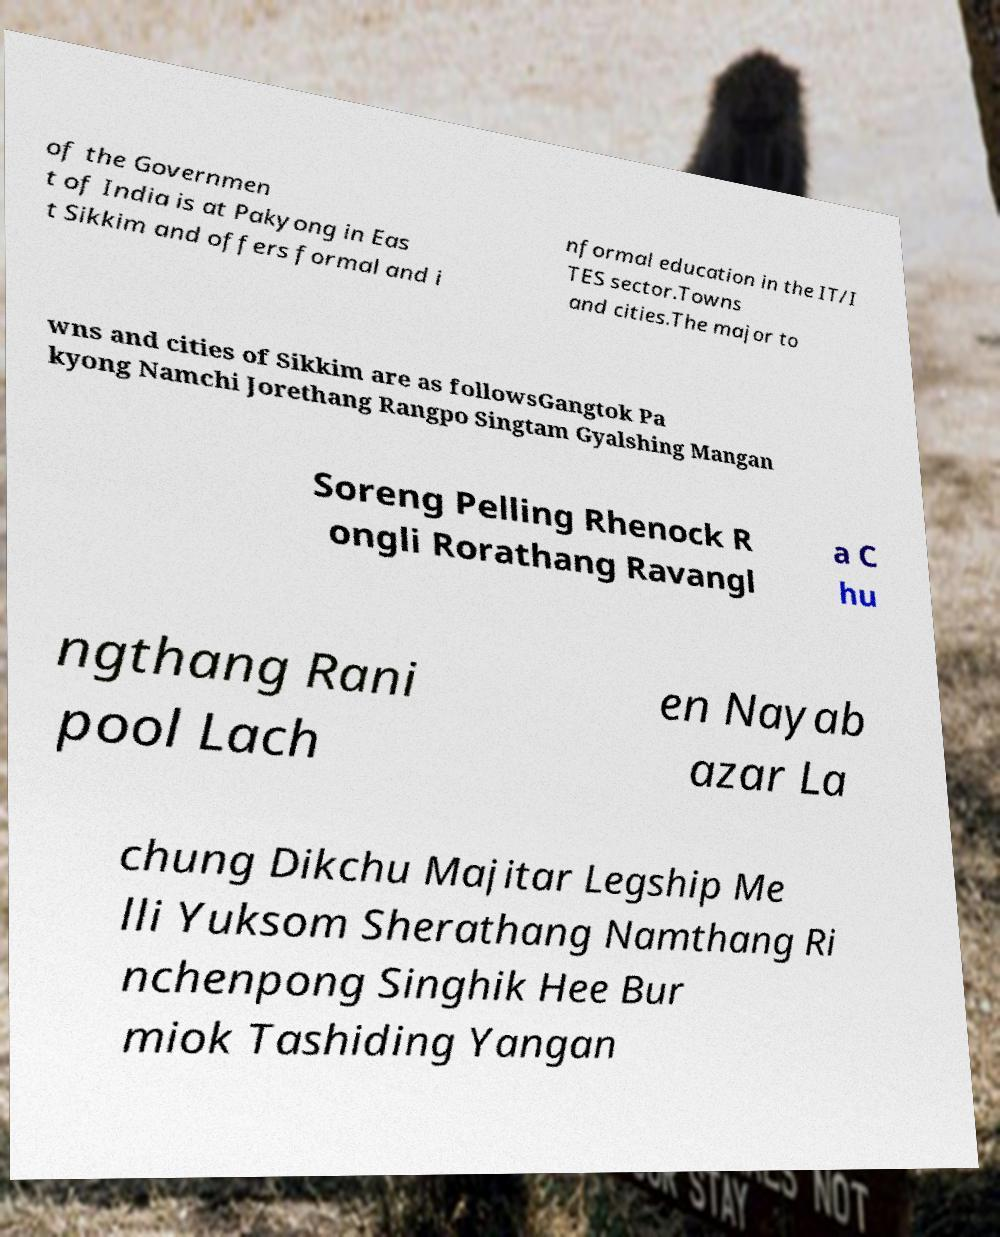Please identify and transcribe the text found in this image. of the Governmen t of India is at Pakyong in Eas t Sikkim and offers formal and i nformal education in the IT/I TES sector.Towns and cities.The major to wns and cities of Sikkim are as followsGangtok Pa kyong Namchi Jorethang Rangpo Singtam Gyalshing Mangan Soreng Pelling Rhenock R ongli Rorathang Ravangl a C hu ngthang Rani pool Lach en Nayab azar La chung Dikchu Majitar Legship Me lli Yuksom Sherathang Namthang Ri nchenpong Singhik Hee Bur miok Tashiding Yangan 